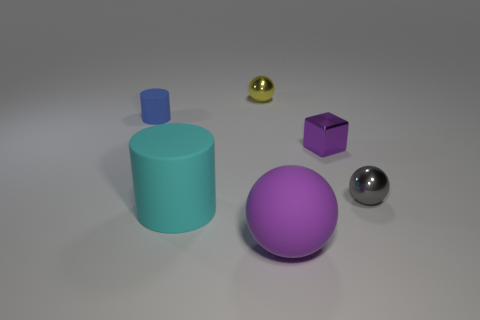There is a tiny metal thing that is the same color as the matte ball; what shape is it?
Offer a terse response. Cube. Is the color of the small metal sphere that is behind the tiny gray thing the same as the sphere to the right of the big purple sphere?
Make the answer very short. No. How many rubber objects are in front of the gray shiny object and behind the purple metal thing?
Your answer should be very brief. 0. What material is the large cyan thing?
Keep it short and to the point. Rubber. What shape is the matte object that is the same size as the block?
Offer a terse response. Cylinder. Is the material of the purple thing that is behind the gray metallic thing the same as the small sphere that is behind the small purple metal thing?
Provide a succinct answer. Yes. How many brown things are there?
Keep it short and to the point. 0. How many other objects are the same shape as the yellow thing?
Offer a very short reply. 2. Does the purple rubber thing have the same shape as the small gray shiny thing?
Provide a short and direct response. Yes. What is the size of the gray metallic sphere?
Offer a very short reply. Small. 